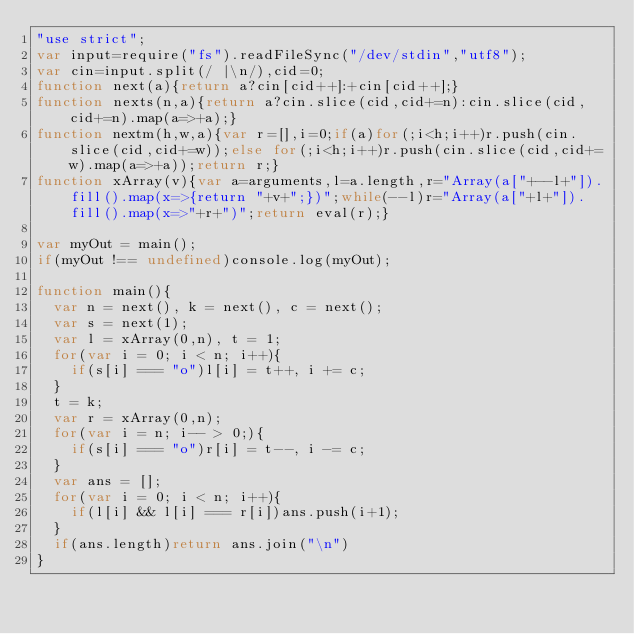Convert code to text. <code><loc_0><loc_0><loc_500><loc_500><_JavaScript_>"use strict";
var input=require("fs").readFileSync("/dev/stdin","utf8");
var cin=input.split(/ |\n/),cid=0;
function next(a){return a?cin[cid++]:+cin[cid++];}
function nexts(n,a){return a?cin.slice(cid,cid+=n):cin.slice(cid,cid+=n).map(a=>+a);}
function nextm(h,w,a){var r=[],i=0;if(a)for(;i<h;i++)r.push(cin.slice(cid,cid+=w));else for(;i<h;i++)r.push(cin.slice(cid,cid+=w).map(a=>+a));return r;}
function xArray(v){var a=arguments,l=a.length,r="Array(a["+--l+"]).fill().map(x=>{return "+v+";})";while(--l)r="Array(a["+l+"]).fill().map(x=>"+r+")";return eval(r);}

var myOut = main();
if(myOut !== undefined)console.log(myOut);

function main(){
  var n = next(), k = next(), c = next();
  var s = next(1);
  var l = xArray(0,n), t = 1;
  for(var i = 0; i < n; i++){
    if(s[i] === "o")l[i] = t++, i += c;
  }
  t = k;
  var r = xArray(0,n);
  for(var i = n; i-- > 0;){
    if(s[i] === "o")r[i] = t--, i -= c;
  }
  var ans = [];
  for(var i = 0; i < n; i++){
    if(l[i] && l[i] === r[i])ans.push(i+1);
  }
  if(ans.length)return ans.join("\n")
}</code> 